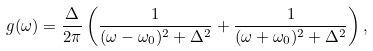Convert formula to latex. <formula><loc_0><loc_0><loc_500><loc_500>g ( \omega ) = \frac { \Delta } { 2 \pi } \left ( \frac { 1 } { ( \omega - \omega _ { 0 } ) ^ { 2 } + \Delta ^ { 2 } } + \frac { 1 } { ( \omega + \omega _ { 0 } ) ^ { 2 } + \Delta ^ { 2 } } \right ) ,</formula> 